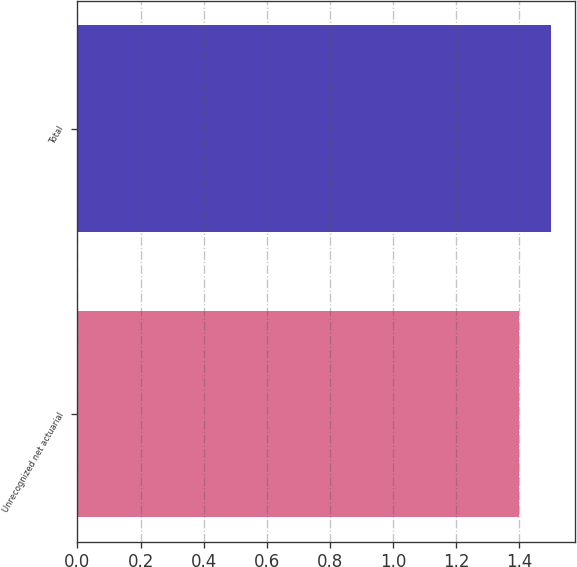<chart> <loc_0><loc_0><loc_500><loc_500><bar_chart><fcel>Unrecognized net actuarial<fcel>Total<nl><fcel>1.4<fcel>1.5<nl></chart> 